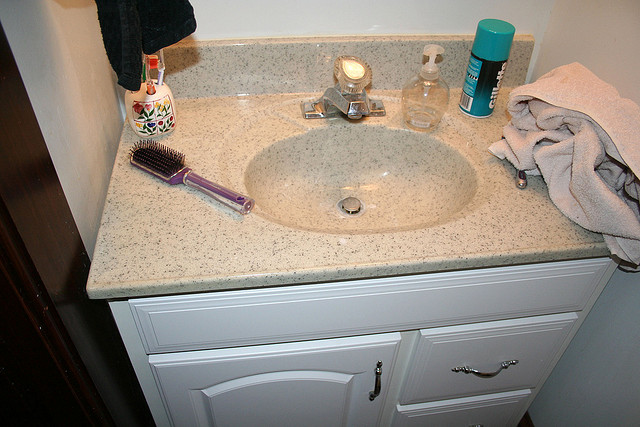<image>What brand of shaving cream is on the counter? I don't know the brand of the shaving cream on the counter. It might be Gillette. What brand of shaving cream is on the counter? It can be seen that the brand of shaving cream on the counter is Gillette. 